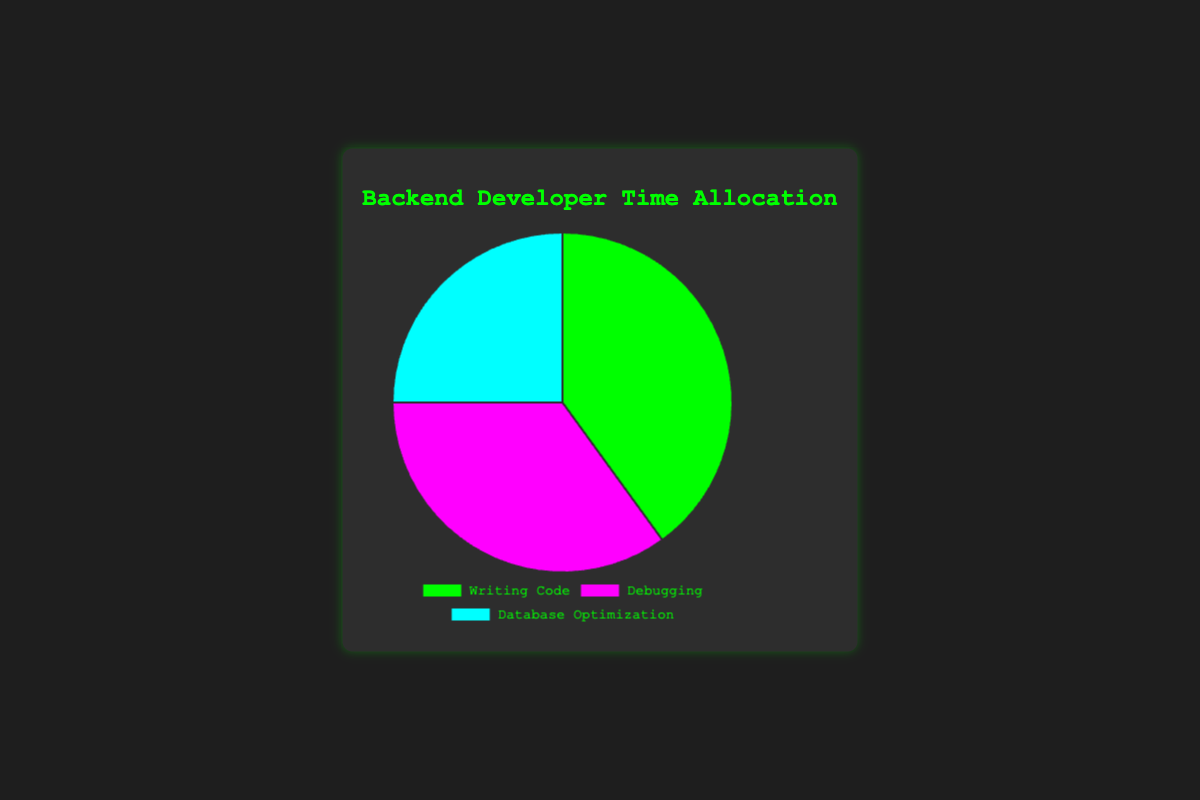What's the largest percentage allocation in the pie chart? The pie chart shows three tasks with their percentage allocations. By observing, 'Writing Code' has the largest percentage at 40%.
Answer: Writing Code What's the total percentage for tasks other than Writing Code? The chart shows Writing Code at 40%, Debugging at 35%, and Database Optimization at 25%. Adding Debugging and Database Optimization percentages (35% + 25%) gives us the total.
Answer: 60% How much more time is spent on Writing Code compared to Database Optimization? The percentage for Writing Code is 40% and for Database Optimization is 25%. Subtracting these percentages (40% - 25%) gives us the difference.
Answer: 15% If you combined Debugging and Database Optimization, what would their total percentage be? The chart lists Debugging at 35% and Database Optimization at 25%. Adding these two percentages (35% + 25%) gives us the total.
Answer: 60% Which task has the smallest percentage allocation? By observing the pie chart, Database Optimization has the smallest percentage allocation at 25%.
Answer: Database Optimization What is the percentage difference between the largest and smallest task allocations? The largest percentage allocation is for Writing Code at 40% and the smallest is for Database Optimization at 25%. The difference is calculated by subtracting 25 from 40 (40% - 25%).
Answer: 15% If the time spent on Debugging is increased by 10%, what would be the new percentage for Debugging? Initially, Debugging is allocated 35%. Adding 10% to this allocation (35% + 10%) gives us the new percentage.
Answer: 45% How does the time spent on Debugging compare to Writing Code in terms of percentage? The chart shows Debugging at 35% and Writing Code at 40%. Comparing these values, Debugging is 5% less than Writing Code.
Answer: Debugging is 5% less What percentage of time is allocated to Writing Code and Debugging combined? The chart shows Writing Code at 40% and Debugging at 35%. Summing these two percentages (40% + 35%) gives us the combined total.
Answer: 75% What colors are used to represent Writing Code and Database Optimization? The chart uses colors to distinguish between tasks. 'Writing Code' is represented by green and 'Database Optimization' is represented by light blue.
Answer: Green and Light Blue 